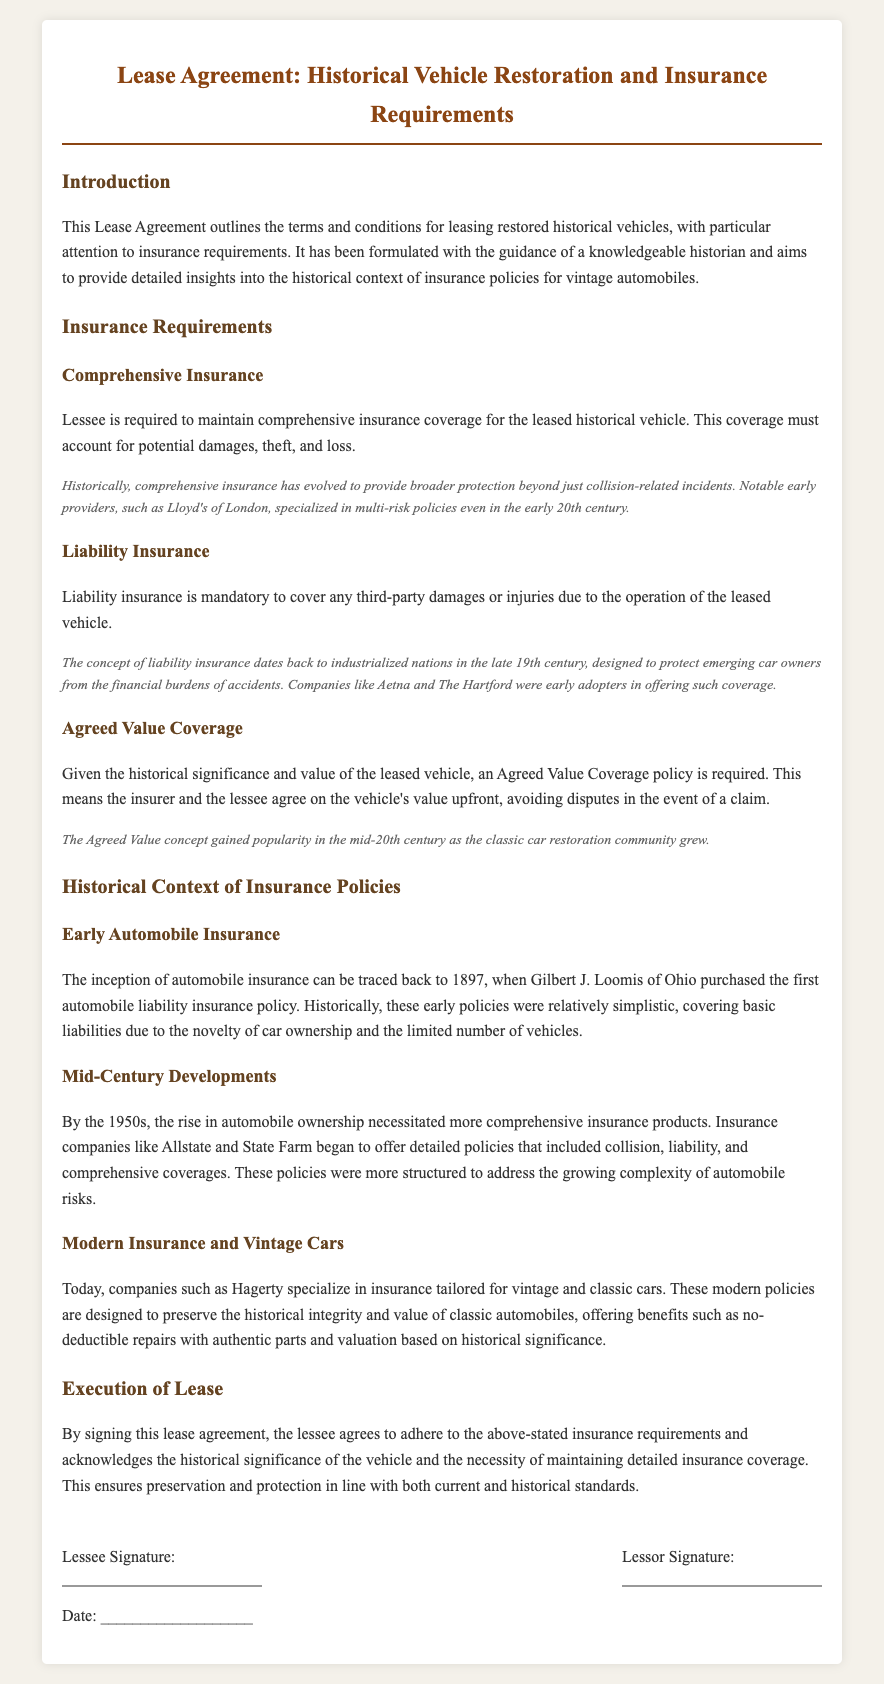What is the title of the document? The title of the document is provided at the top of the page in a prominent position.
Answer: Lease Agreement: Historical Vehicle Restoration and Insurance Requirements Who is required to maintain comprehensive insurance coverage? The document states the responsibility of the lessee regarding comprehensive insurance.
Answer: Lessee What is one major early provider of comprehensive insurance mentioned? The document highlights some early providers of insurance as it discusses the evolution of policies.
Answer: Lloyd's of London When did Gilbert J. Loomis purchase the first automobile liability insurance policy? The historical context section provides the year of this milestone event in automobile insurance history.
Answer: 1897 What type of insurance must be maintained for third-party damages? This specific insurance coverage is required as outlined in the document under insurance requirements.
Answer: Liability insurance What does Agreed Value Coverage involve? The document explains this coverage policy and how it is determined between the insurer and the lessee.
Answer: Agree on the vehicle's value upfront Which insurance company specializes in vintage car insurance? The document mentions a company that focuses on vintage and classic car insurance in the modern context.
Answer: Hagerty What is the historical note regarding liability insurance? The document includes a historical note explaining the background of liability insurance.
Answer: Protect emerging car owners from financial burdens In which decade did comprehensive insurance products become more structured? The document discusses developments in automobile insurance around this specific time period.
Answer: 1950s 